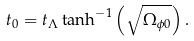<formula> <loc_0><loc_0><loc_500><loc_500>t _ { 0 } = t _ { \Lambda } \tanh ^ { - 1 } \left ( \sqrt { \Omega _ { \phi 0 } } \right ) .</formula> 